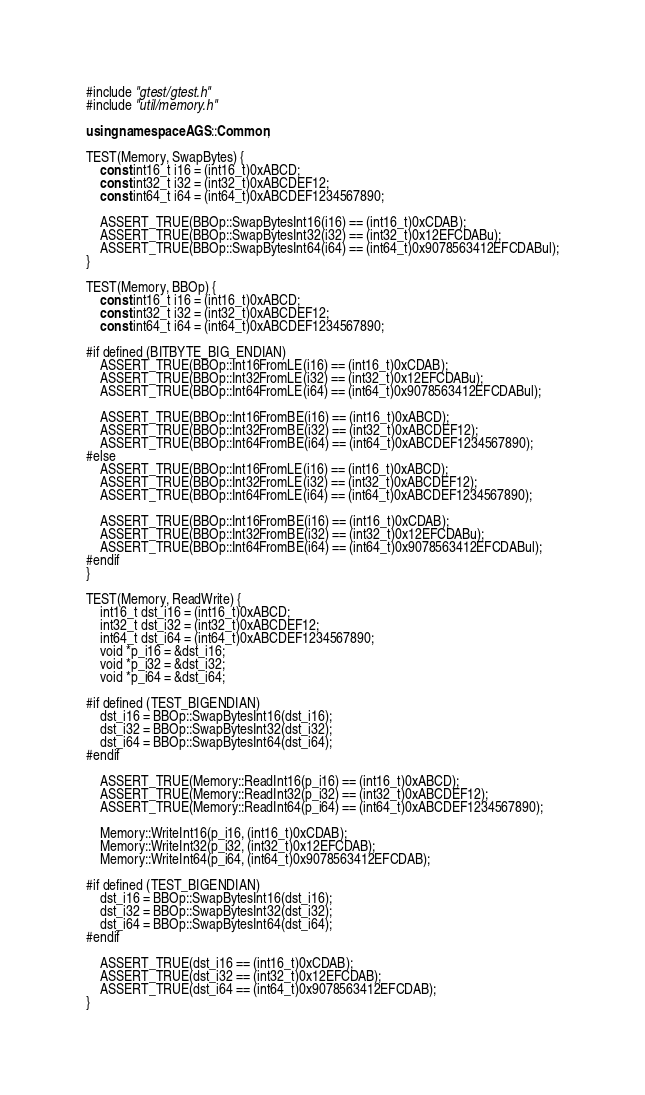Convert code to text. <code><loc_0><loc_0><loc_500><loc_500><_C++_>#include "gtest/gtest.h"
#include "util/memory.h"

using namespace AGS::Common;

TEST(Memory, SwapBytes) {
    const int16_t i16 = (int16_t)0xABCD;
    const int32_t i32 = (int32_t)0xABCDEF12;
    const int64_t i64 = (int64_t)0xABCDEF1234567890;

    ASSERT_TRUE(BBOp::SwapBytesInt16(i16) == (int16_t)0xCDAB);
    ASSERT_TRUE(BBOp::SwapBytesInt32(i32) == (int32_t)0x12EFCDABu);
    ASSERT_TRUE(BBOp::SwapBytesInt64(i64) == (int64_t)0x9078563412EFCDABul);
}

TEST(Memory, BBOp) {
    const int16_t i16 = (int16_t)0xABCD;
    const int32_t i32 = (int32_t)0xABCDEF12;
    const int64_t i64 = (int64_t)0xABCDEF1234567890;

#if defined (BITBYTE_BIG_ENDIAN)
    ASSERT_TRUE(BBOp::Int16FromLE(i16) == (int16_t)0xCDAB);
    ASSERT_TRUE(BBOp::Int32FromLE(i32) == (int32_t)0x12EFCDABu);
    ASSERT_TRUE(BBOp::Int64FromLE(i64) == (int64_t)0x9078563412EFCDABul);

    ASSERT_TRUE(BBOp::Int16FromBE(i16) == (int16_t)0xABCD);
    ASSERT_TRUE(BBOp::Int32FromBE(i32) == (int32_t)0xABCDEF12);
    ASSERT_TRUE(BBOp::Int64FromBE(i64) == (int64_t)0xABCDEF1234567890);
#else
    ASSERT_TRUE(BBOp::Int16FromLE(i16) == (int16_t)0xABCD);
    ASSERT_TRUE(BBOp::Int32FromLE(i32) == (int32_t)0xABCDEF12);
    ASSERT_TRUE(BBOp::Int64FromLE(i64) == (int64_t)0xABCDEF1234567890);

    ASSERT_TRUE(BBOp::Int16FromBE(i16) == (int16_t)0xCDAB);
    ASSERT_TRUE(BBOp::Int32FromBE(i32) == (int32_t)0x12EFCDABu);
    ASSERT_TRUE(BBOp::Int64FromBE(i64) == (int64_t)0x9078563412EFCDABul);
#endif
}

TEST(Memory, ReadWrite) {
    int16_t dst_i16 = (int16_t)0xABCD;
    int32_t dst_i32 = (int32_t)0xABCDEF12;
    int64_t dst_i64 = (int64_t)0xABCDEF1234567890;
    void *p_i16 = &dst_i16;
    void *p_i32 = &dst_i32;
    void *p_i64 = &dst_i64;

#if defined (TEST_BIGENDIAN)
    dst_i16 = BBOp::SwapBytesInt16(dst_i16);
    dst_i32 = BBOp::SwapBytesInt32(dst_i32);
    dst_i64 = BBOp::SwapBytesInt64(dst_i64);
#endif

    ASSERT_TRUE(Memory::ReadInt16(p_i16) == (int16_t)0xABCD);
    ASSERT_TRUE(Memory::ReadInt32(p_i32) == (int32_t)0xABCDEF12);
    ASSERT_TRUE(Memory::ReadInt64(p_i64) == (int64_t)0xABCDEF1234567890);

    Memory::WriteInt16(p_i16, (int16_t)0xCDAB);
    Memory::WriteInt32(p_i32, (int32_t)0x12EFCDAB);
    Memory::WriteInt64(p_i64, (int64_t)0x9078563412EFCDAB);

#if defined (TEST_BIGENDIAN)
    dst_i16 = BBOp::SwapBytesInt16(dst_i16);
    dst_i32 = BBOp::SwapBytesInt32(dst_i32);
    dst_i64 = BBOp::SwapBytesInt64(dst_i64);
#endif

    ASSERT_TRUE(dst_i16 == (int16_t)0xCDAB);
    ASSERT_TRUE(dst_i32 == (int32_t)0x12EFCDAB);
    ASSERT_TRUE(dst_i64 == (int64_t)0x9078563412EFCDAB);
}
</code> 